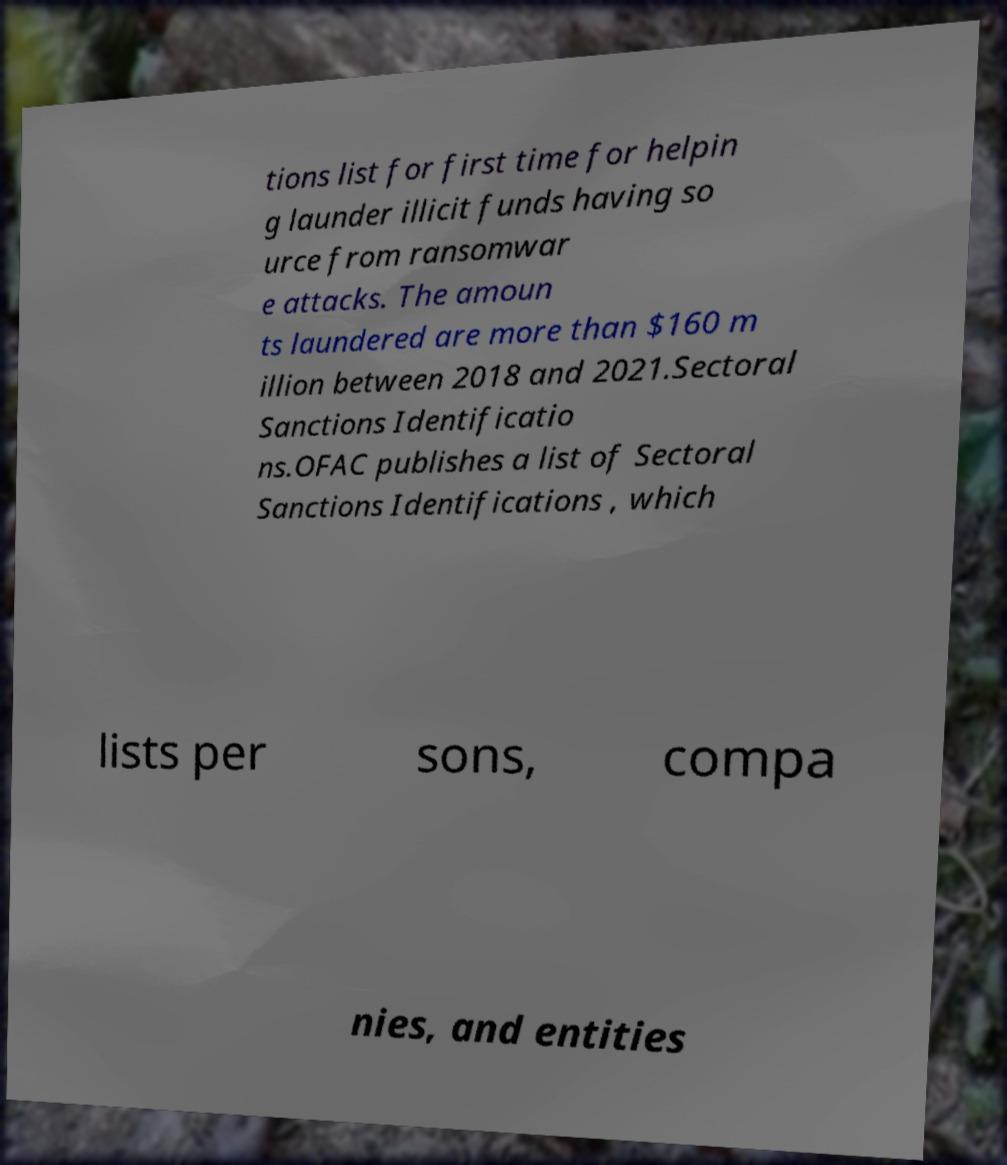Could you assist in decoding the text presented in this image and type it out clearly? tions list for first time for helpin g launder illicit funds having so urce from ransomwar e attacks. The amoun ts laundered are more than $160 m illion between 2018 and 2021.Sectoral Sanctions Identificatio ns.OFAC publishes a list of Sectoral Sanctions Identifications , which lists per sons, compa nies, and entities 